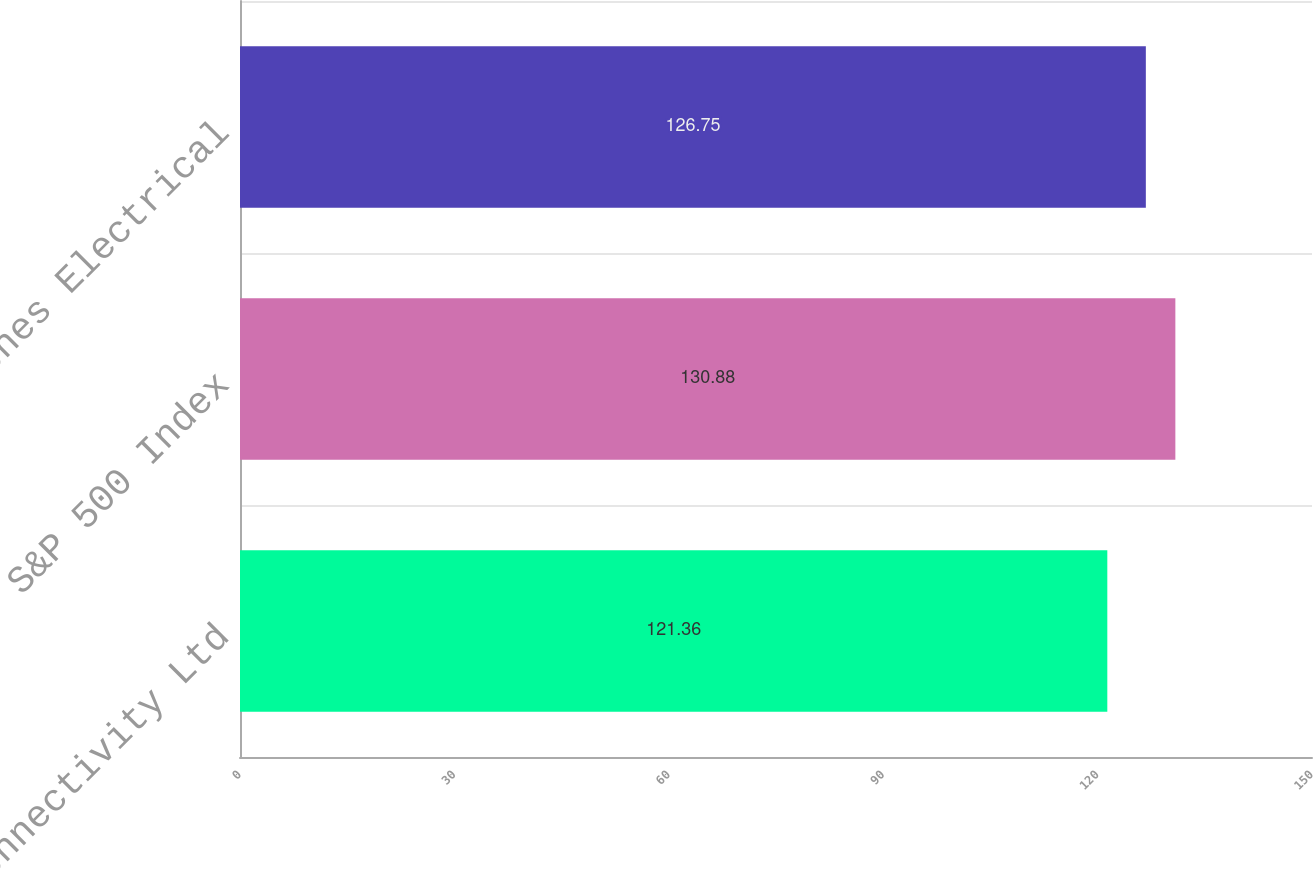Convert chart to OTSL. <chart><loc_0><loc_0><loc_500><loc_500><bar_chart><fcel>TE Connectivity Ltd<fcel>S&P 500 Index<fcel>Dow Jones Electrical<nl><fcel>121.36<fcel>130.88<fcel>126.75<nl></chart> 